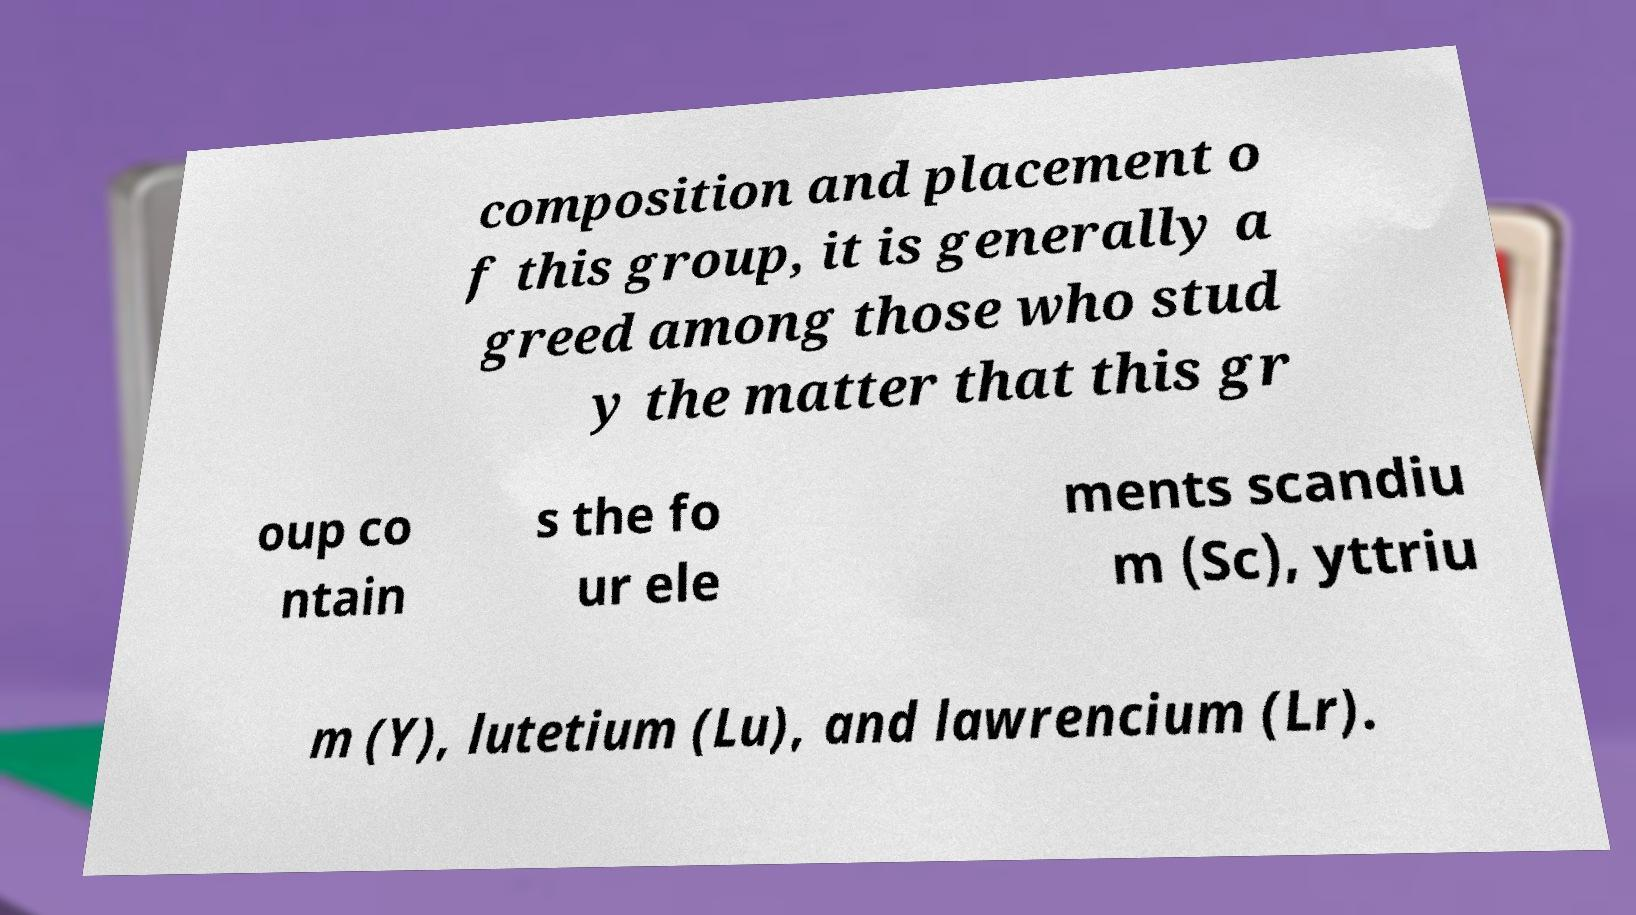Can you accurately transcribe the text from the provided image for me? composition and placement o f this group, it is generally a greed among those who stud y the matter that this gr oup co ntain s the fo ur ele ments scandiu m (Sc), yttriu m (Y), lutetium (Lu), and lawrencium (Lr). 